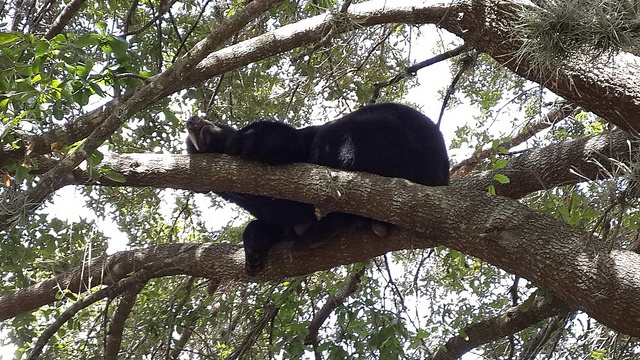Describe the objects in this image and their specific colors. I can see a bear in gray, black, and darkgray tones in this image. 